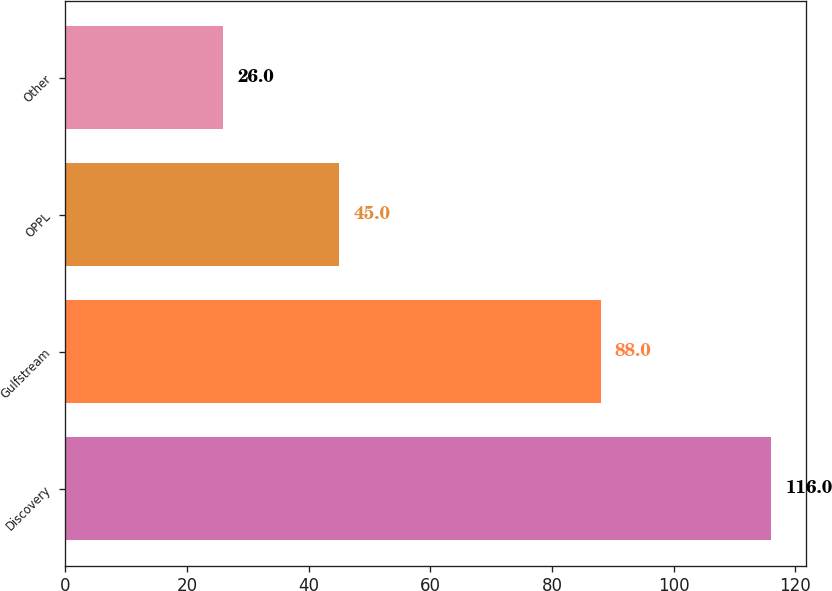Convert chart to OTSL. <chart><loc_0><loc_0><loc_500><loc_500><bar_chart><fcel>Discovery<fcel>Gulfstream<fcel>OPPL<fcel>Other<nl><fcel>116<fcel>88<fcel>45<fcel>26<nl></chart> 